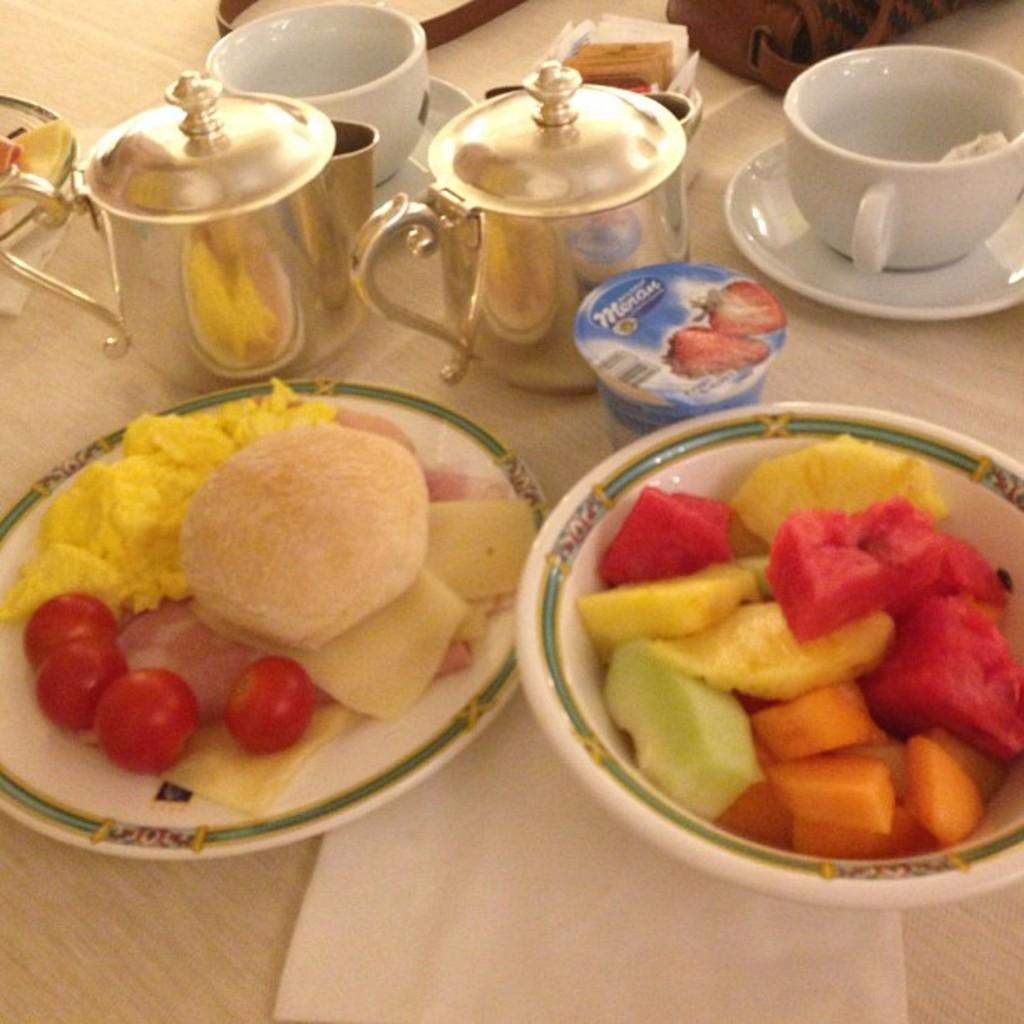What type of tableware can be seen in the image? There are cups and saucers in the image. What is placed on the plates in the image? There are food items on plates in the image. What is the surface on which the cups, saucers, and plates are placed? There are other objects on a wooden surface in the image. What type of mask is being worn by the food items on the plates in the image? There are no masks present in the image, as the image features cups, saucers, and food items on plates. How much sugar is visible in the image? There is no sugar present in the image; it features cups, saucers, and food items on plates. 